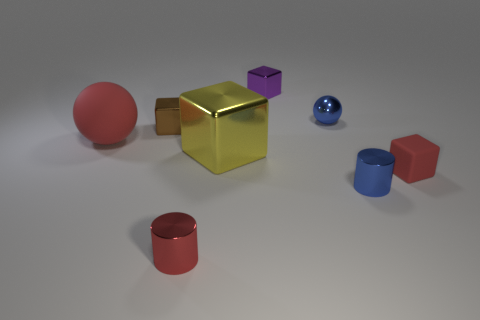Add 2 small brown matte cubes. How many objects exist? 10 Subtract all cylinders. How many objects are left? 6 Subtract 0 purple cylinders. How many objects are left? 8 Subtract all rubber balls. Subtract all small balls. How many objects are left? 6 Add 7 large red things. How many large red things are left? 8 Add 6 matte cubes. How many matte cubes exist? 7 